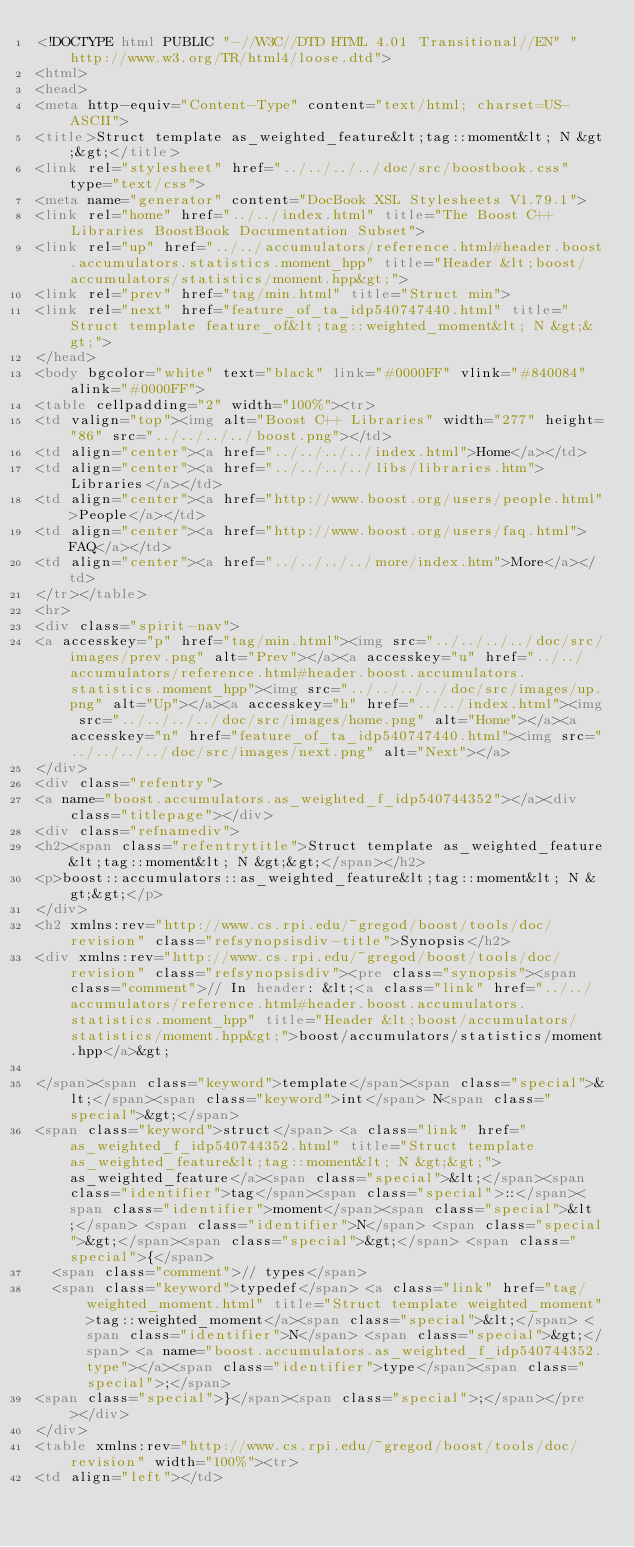<code> <loc_0><loc_0><loc_500><loc_500><_HTML_><!DOCTYPE html PUBLIC "-//W3C//DTD HTML 4.01 Transitional//EN" "http://www.w3.org/TR/html4/loose.dtd">
<html>
<head>
<meta http-equiv="Content-Type" content="text/html; charset=US-ASCII">
<title>Struct template as_weighted_feature&lt;tag::moment&lt; N &gt;&gt;</title>
<link rel="stylesheet" href="../../../../doc/src/boostbook.css" type="text/css">
<meta name="generator" content="DocBook XSL Stylesheets V1.79.1">
<link rel="home" href="../../index.html" title="The Boost C++ Libraries BoostBook Documentation Subset">
<link rel="up" href="../../accumulators/reference.html#header.boost.accumulators.statistics.moment_hpp" title="Header &lt;boost/accumulators/statistics/moment.hpp&gt;">
<link rel="prev" href="tag/min.html" title="Struct min">
<link rel="next" href="feature_of_ta_idp540747440.html" title="Struct template feature_of&lt;tag::weighted_moment&lt; N &gt;&gt;">
</head>
<body bgcolor="white" text="black" link="#0000FF" vlink="#840084" alink="#0000FF">
<table cellpadding="2" width="100%"><tr>
<td valign="top"><img alt="Boost C++ Libraries" width="277" height="86" src="../../../../boost.png"></td>
<td align="center"><a href="../../../../index.html">Home</a></td>
<td align="center"><a href="../../../../libs/libraries.htm">Libraries</a></td>
<td align="center"><a href="http://www.boost.org/users/people.html">People</a></td>
<td align="center"><a href="http://www.boost.org/users/faq.html">FAQ</a></td>
<td align="center"><a href="../../../../more/index.htm">More</a></td>
</tr></table>
<hr>
<div class="spirit-nav">
<a accesskey="p" href="tag/min.html"><img src="../../../../doc/src/images/prev.png" alt="Prev"></a><a accesskey="u" href="../../accumulators/reference.html#header.boost.accumulators.statistics.moment_hpp"><img src="../../../../doc/src/images/up.png" alt="Up"></a><a accesskey="h" href="../../index.html"><img src="../../../../doc/src/images/home.png" alt="Home"></a><a accesskey="n" href="feature_of_ta_idp540747440.html"><img src="../../../../doc/src/images/next.png" alt="Next"></a>
</div>
<div class="refentry">
<a name="boost.accumulators.as_weighted_f_idp540744352"></a><div class="titlepage"></div>
<div class="refnamediv">
<h2><span class="refentrytitle">Struct template as_weighted_feature&lt;tag::moment&lt; N &gt;&gt;</span></h2>
<p>boost::accumulators::as_weighted_feature&lt;tag::moment&lt; N &gt;&gt;</p>
</div>
<h2 xmlns:rev="http://www.cs.rpi.edu/~gregod/boost/tools/doc/revision" class="refsynopsisdiv-title">Synopsis</h2>
<div xmlns:rev="http://www.cs.rpi.edu/~gregod/boost/tools/doc/revision" class="refsynopsisdiv"><pre class="synopsis"><span class="comment">// In header: &lt;<a class="link" href="../../accumulators/reference.html#header.boost.accumulators.statistics.moment_hpp" title="Header &lt;boost/accumulators/statistics/moment.hpp&gt;">boost/accumulators/statistics/moment.hpp</a>&gt;

</span><span class="keyword">template</span><span class="special">&lt;</span><span class="keyword">int</span> N<span class="special">&gt;</span> 
<span class="keyword">struct</span> <a class="link" href="as_weighted_f_idp540744352.html" title="Struct template as_weighted_feature&lt;tag::moment&lt; N &gt;&gt;">as_weighted_feature</a><span class="special">&lt;</span><span class="identifier">tag</span><span class="special">::</span><span class="identifier">moment</span><span class="special">&lt;</span> <span class="identifier">N</span> <span class="special">&gt;</span><span class="special">&gt;</span> <span class="special">{</span>
  <span class="comment">// types</span>
  <span class="keyword">typedef</span> <a class="link" href="tag/weighted_moment.html" title="Struct template weighted_moment">tag::weighted_moment</a><span class="special">&lt;</span> <span class="identifier">N</span> <span class="special">&gt;</span> <a name="boost.accumulators.as_weighted_f_idp540744352.type"></a><span class="identifier">type</span><span class="special">;</span>
<span class="special">}</span><span class="special">;</span></pre></div>
</div>
<table xmlns:rev="http://www.cs.rpi.edu/~gregod/boost/tools/doc/revision" width="100%"><tr>
<td align="left"></td></code> 